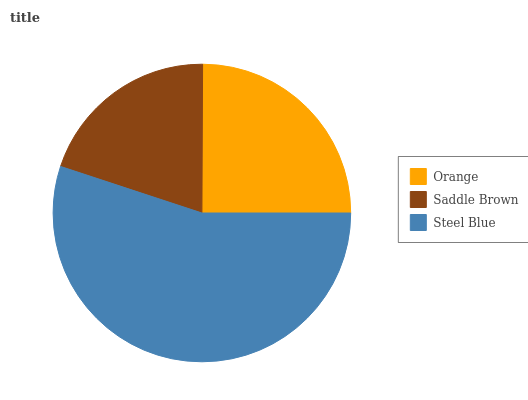Is Saddle Brown the minimum?
Answer yes or no. Yes. Is Steel Blue the maximum?
Answer yes or no. Yes. Is Steel Blue the minimum?
Answer yes or no. No. Is Saddle Brown the maximum?
Answer yes or no. No. Is Steel Blue greater than Saddle Brown?
Answer yes or no. Yes. Is Saddle Brown less than Steel Blue?
Answer yes or no. Yes. Is Saddle Brown greater than Steel Blue?
Answer yes or no. No. Is Steel Blue less than Saddle Brown?
Answer yes or no. No. Is Orange the high median?
Answer yes or no. Yes. Is Orange the low median?
Answer yes or no. Yes. Is Saddle Brown the high median?
Answer yes or no. No. Is Saddle Brown the low median?
Answer yes or no. No. 